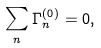<formula> <loc_0><loc_0><loc_500><loc_500>\sum _ { n } \Gamma ^ { ( 0 ) } _ { n } = 0 ,</formula> 